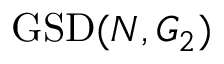<formula> <loc_0><loc_0><loc_500><loc_500>G S D ( N , G _ { 2 } )</formula> 